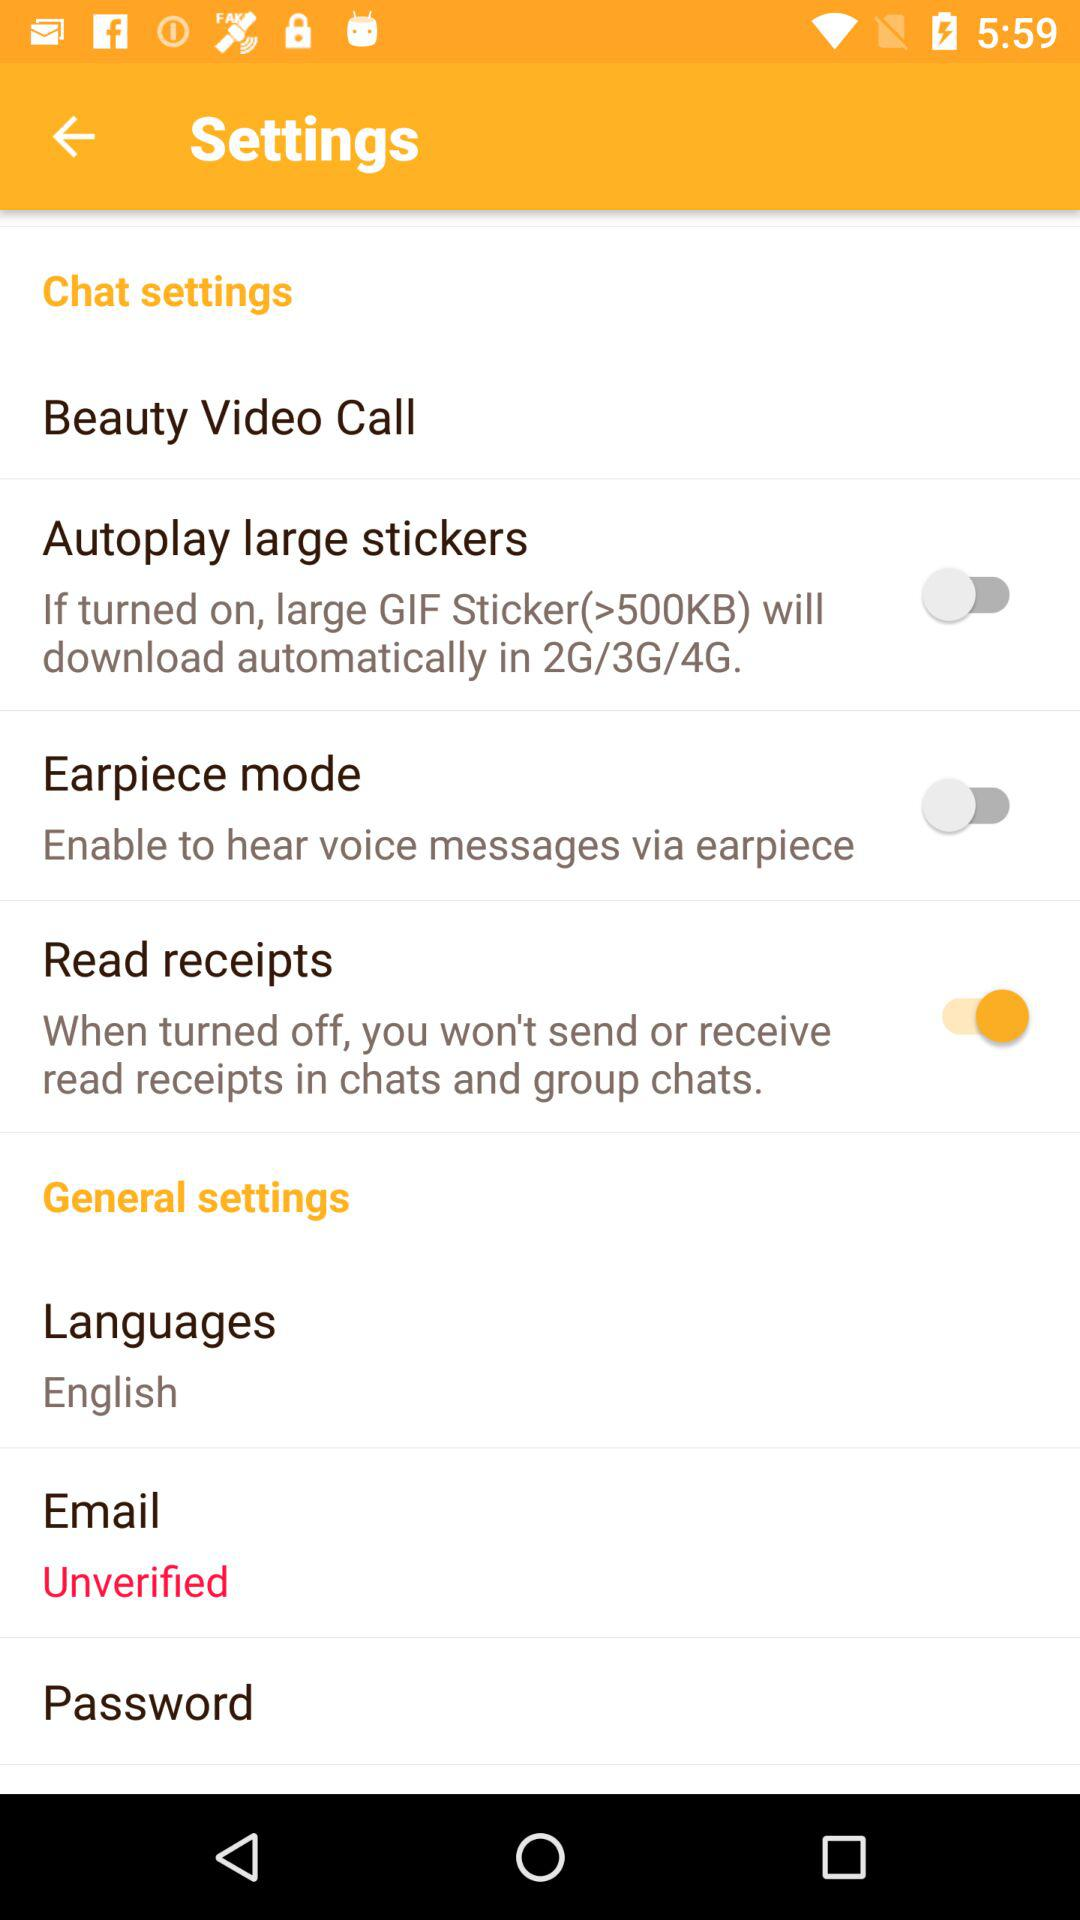What is the status of the "Autoplay large stickers" setting? The status is "off". 